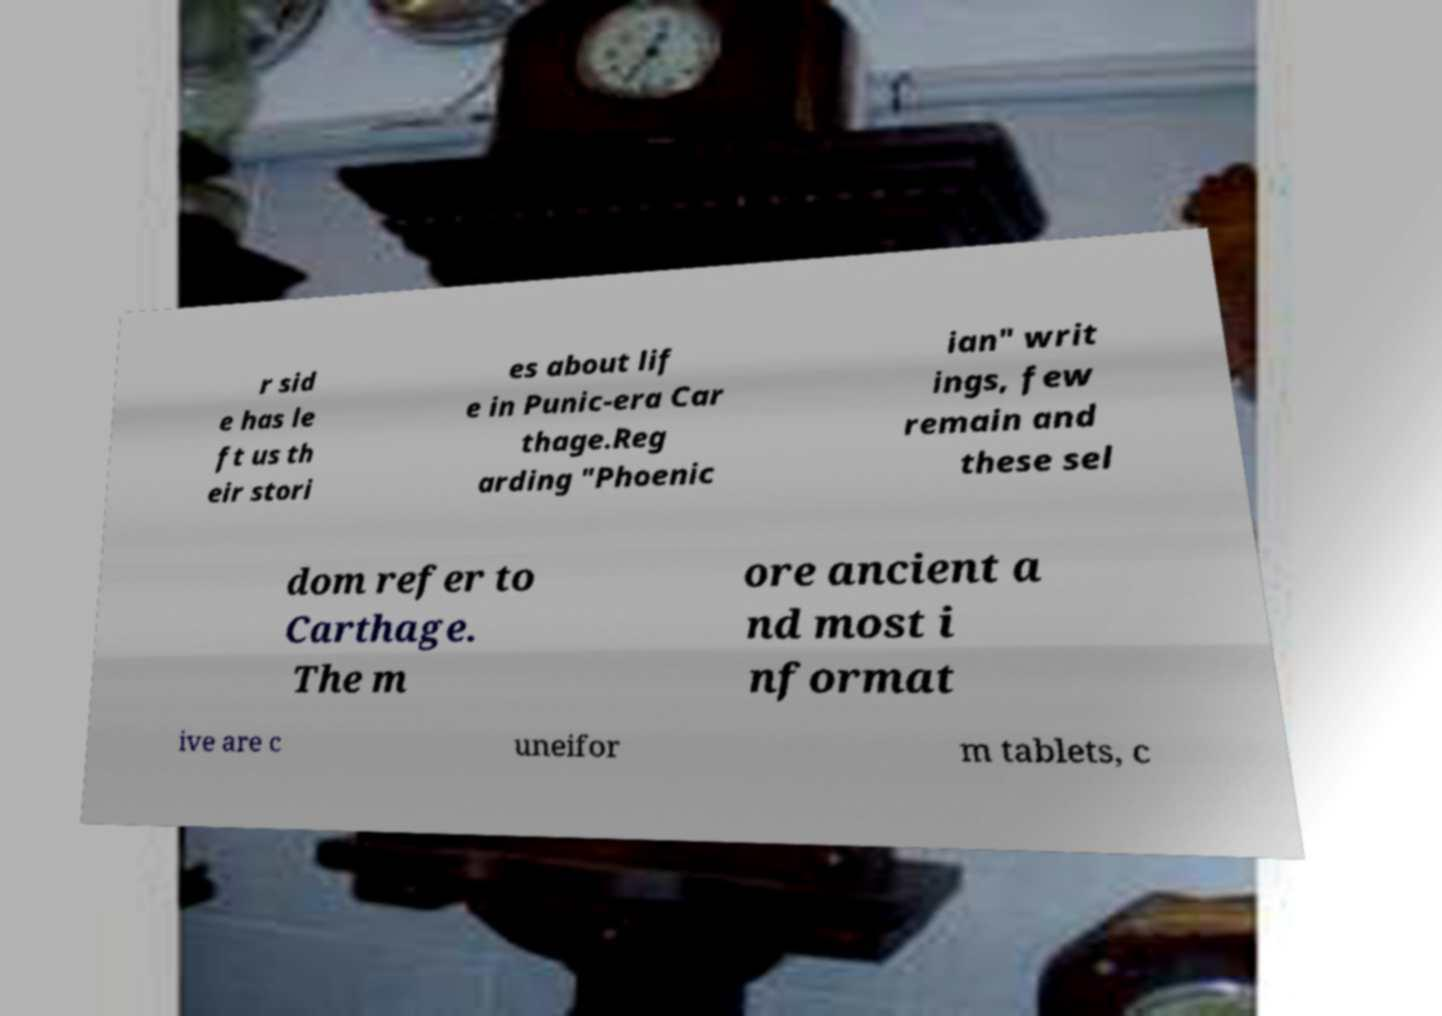Can you read and provide the text displayed in the image?This photo seems to have some interesting text. Can you extract and type it out for me? r sid e has le ft us th eir stori es about lif e in Punic-era Car thage.Reg arding "Phoenic ian" writ ings, few remain and these sel dom refer to Carthage. The m ore ancient a nd most i nformat ive are c uneifor m tablets, c 